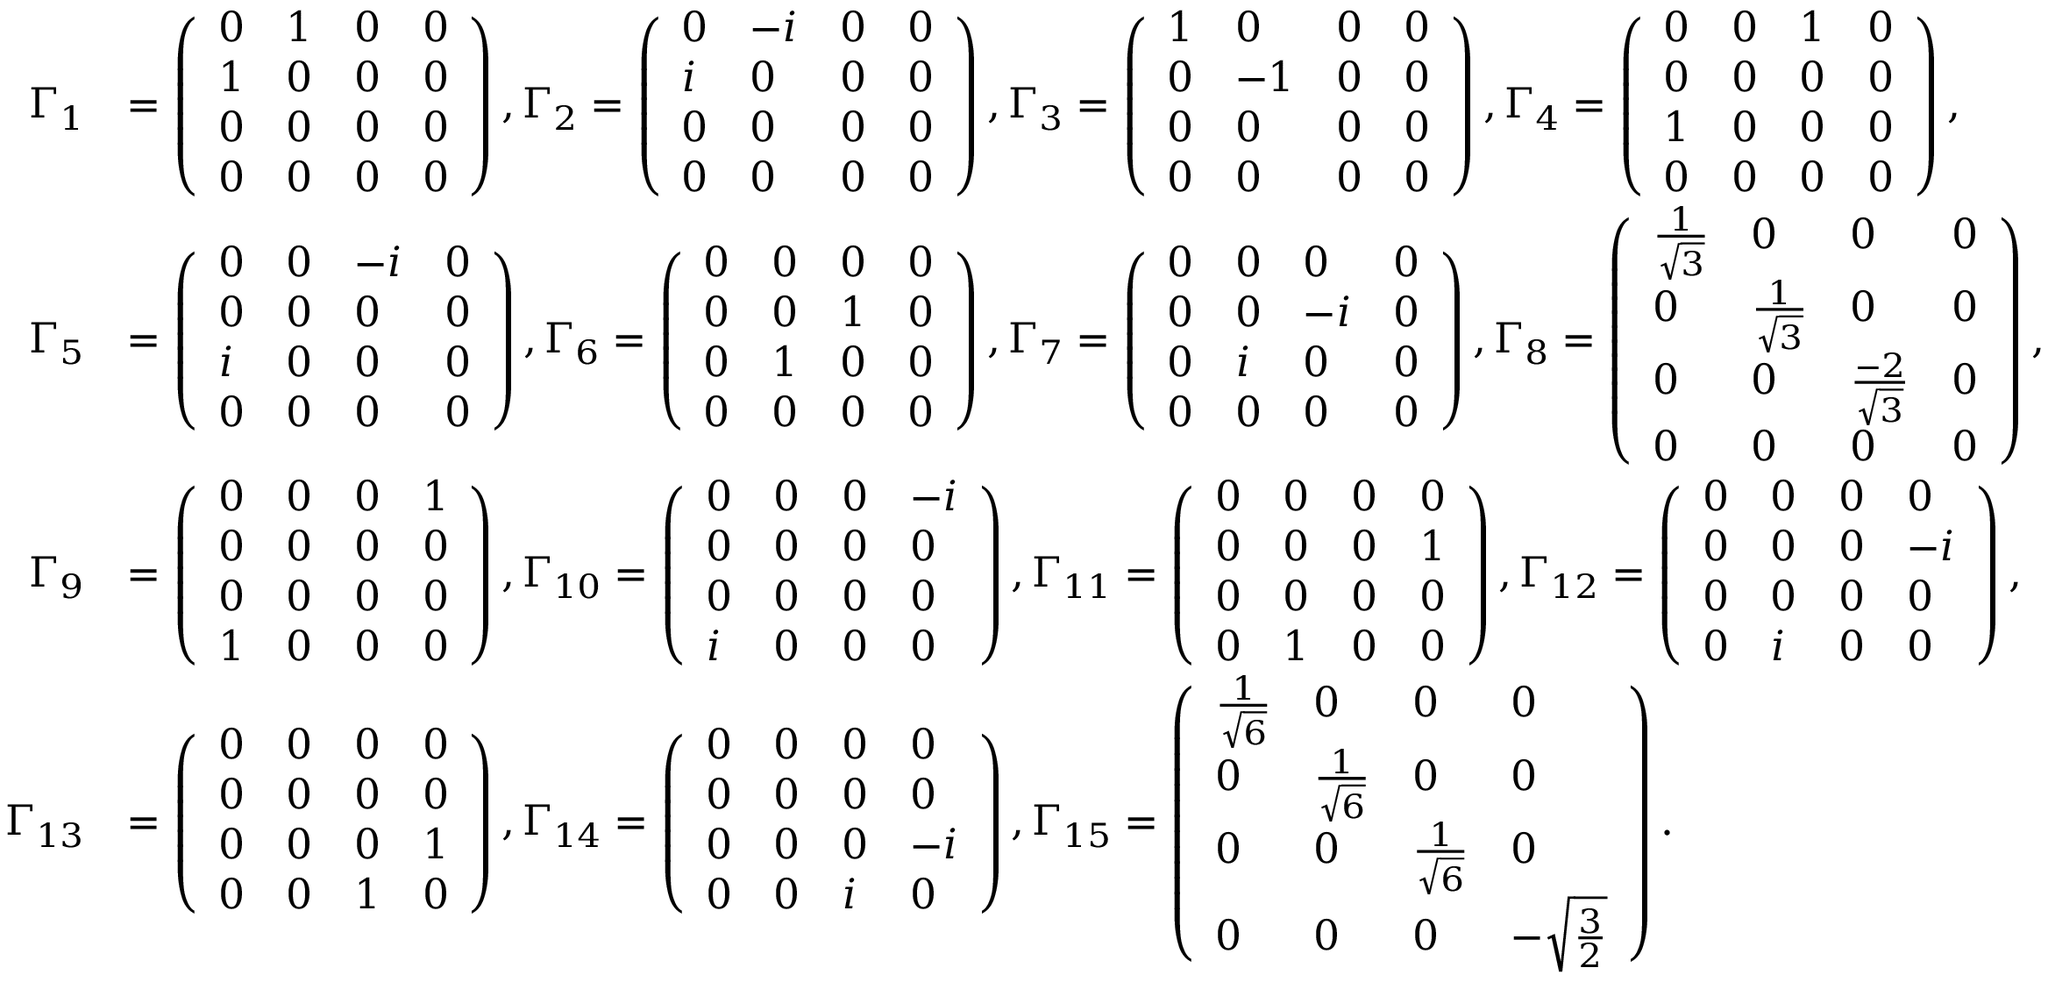Convert formula to latex. <formula><loc_0><loc_0><loc_500><loc_500>\begin{array} { r l } { \Gamma _ { 1 } } & { = \left ( \begin{array} { l l l l } { 0 } & { 1 } & { 0 } & { 0 } \\ { 1 } & { 0 } & { 0 } & { 0 } \\ { 0 } & { 0 } & { 0 } & { 0 } \\ { 0 } & { 0 } & { 0 } & { 0 } \end{array} \right ) , \Gamma _ { 2 } = \left ( \begin{array} { l l l l } { 0 } & { - i } & { 0 } & { 0 } \\ { i } & { 0 } & { 0 } & { 0 } \\ { 0 } & { 0 } & { 0 } & { 0 } \\ { 0 } & { 0 } & { 0 } & { 0 } \end{array} \right ) , \Gamma _ { 3 } = \left ( \begin{array} { l l l l } { 1 } & { 0 } & { 0 } & { 0 } \\ { 0 } & { - 1 } & { 0 } & { 0 } \\ { 0 } & { 0 } & { 0 } & { 0 } \\ { 0 } & { 0 } & { 0 } & { 0 } \end{array} \right ) , \Gamma _ { 4 } = \left ( \begin{array} { l l l l } { 0 } & { 0 } & { 1 } & { 0 } \\ { 0 } & { 0 } & { 0 } & { 0 } \\ { 1 } & { 0 } & { 0 } & { 0 } \\ { 0 } & { 0 } & { 0 } & { 0 } \end{array} \right ) , } \\ { \Gamma _ { 5 } } & { = \left ( \begin{array} { l l l l } { 0 } & { 0 } & { - i } & { 0 } \\ { 0 } & { 0 } & { 0 } & { 0 } \\ { i } & { 0 } & { 0 } & { 0 } \\ { 0 } & { 0 } & { 0 } & { 0 } \end{array} \right ) , \Gamma _ { 6 } = \left ( \begin{array} { l l l l } { 0 } & { 0 } & { 0 } & { 0 } \\ { 0 } & { 0 } & { 1 } & { 0 } \\ { 0 } & { 1 } & { 0 } & { 0 } \\ { 0 } & { 0 } & { 0 } & { 0 } \end{array} \right ) , \Gamma _ { 7 } = \left ( \begin{array} { l l l l } { 0 } & { 0 } & { 0 } & { 0 } \\ { 0 } & { 0 } & { - i } & { 0 } \\ { 0 } & { i } & { 0 } & { 0 } \\ { 0 } & { 0 } & { 0 } & { 0 } \end{array} \right ) , \Gamma _ { 8 } = \left ( \begin{array} { l l l l } { \frac { 1 } { \sqrt { 3 } } } & { 0 } & { 0 } & { 0 } \\ { 0 } & { \frac { 1 } { \sqrt { 3 } } } & { 0 } & { 0 } \\ { 0 } & { 0 } & { \frac { - 2 } { \sqrt { 3 } } } & { 0 } \\ { 0 } & { 0 } & { 0 } & { 0 } \end{array} \right ) , } \\ { \Gamma _ { 9 } } & { = \left ( \begin{array} { l l l l } { 0 } & { 0 } & { 0 } & { 1 } \\ { 0 } & { 0 } & { 0 } & { 0 } \\ { 0 } & { 0 } & { 0 } & { 0 } \\ { 1 } & { 0 } & { 0 } & { 0 } \end{array} \right ) , \Gamma _ { 1 0 } = \left ( \begin{array} { l l l l } { 0 } & { 0 } & { 0 } & { - i } \\ { 0 } & { 0 } & { 0 } & { 0 } \\ { 0 } & { 0 } & { 0 } & { 0 } \\ { i } & { 0 } & { 0 } & { 0 } \end{array} \right ) , \Gamma _ { 1 1 } = \left ( \begin{array} { l l l l } { 0 } & { 0 } & { 0 } & { 0 } \\ { 0 } & { 0 } & { 0 } & { 1 } \\ { 0 } & { 0 } & { 0 } & { 0 } \\ { 0 } & { 1 } & { 0 } & { 0 } \end{array} \right ) , \Gamma _ { 1 2 } = \left ( \begin{array} { l l l l } { 0 } & { 0 } & { 0 } & { 0 } \\ { 0 } & { 0 } & { 0 } & { - i } \\ { 0 } & { 0 } & { 0 } & { 0 } \\ { 0 } & { i } & { 0 } & { 0 } \end{array} \right ) , } \\ { \Gamma _ { 1 3 } } & { = \left ( \begin{array} { l l l l } { 0 } & { 0 } & { 0 } & { 0 } \\ { 0 } & { 0 } & { 0 } & { 0 } \\ { 0 } & { 0 } & { 0 } & { 1 } \\ { 0 } & { 0 } & { 1 } & { 0 } \end{array} \right ) , \Gamma _ { 1 4 } = \left ( \begin{array} { l l l l } { 0 } & { 0 } & { 0 } & { 0 } \\ { 0 } & { 0 } & { 0 } & { 0 } \\ { 0 } & { 0 } & { 0 } & { - i } \\ { 0 } & { 0 } & { i } & { 0 } \end{array} \right ) , \Gamma _ { 1 5 } = \left ( \begin{array} { l l l l } { \frac { 1 } { \sqrt { 6 } } } & { 0 } & { 0 } & { 0 } \\ { 0 } & { \frac { 1 } { \sqrt { 6 } } } & { 0 } & { 0 } \\ { 0 } & { 0 } & { \frac { 1 } { \sqrt { 6 } } } & { 0 } \\ { 0 } & { 0 } & { 0 } & { - \sqrt { \frac { 3 } { 2 } } } \end{array} \right ) . } \end{array}</formula> 